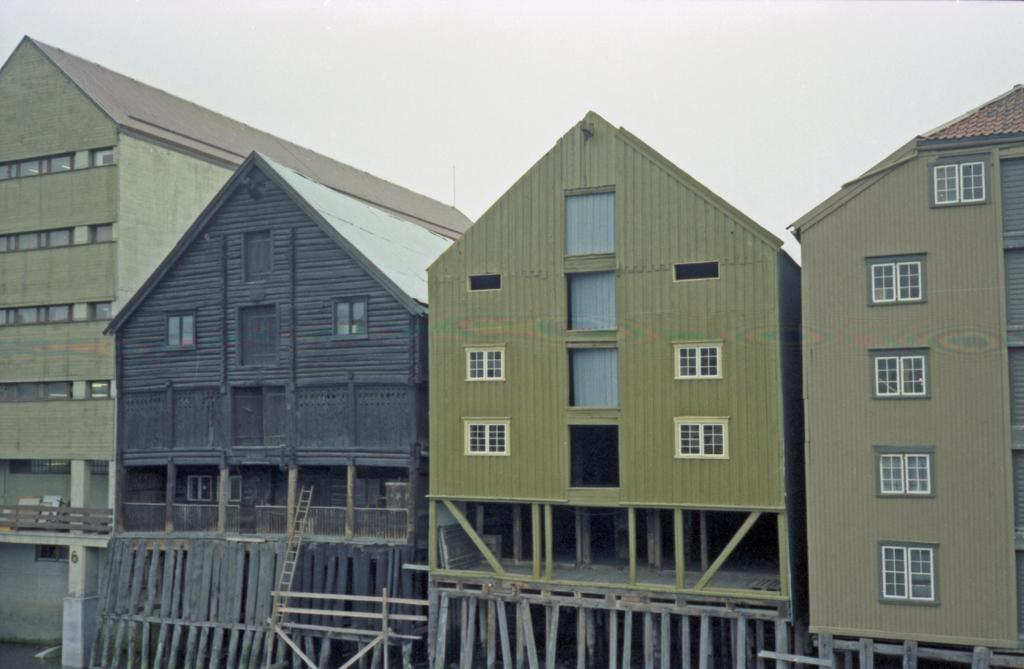What type of structures can be seen in the image? There are buildings in the image. Can you identify any specific objects in the image? Yes, there is a ladder in the image. How many sacks can be seen on the roof of the buildings in the image? There are no sacks visible on the roof of the buildings in the image. Is there a crown on top of any of the buildings in the image? There is no crown present on any of the buildings in the image. 